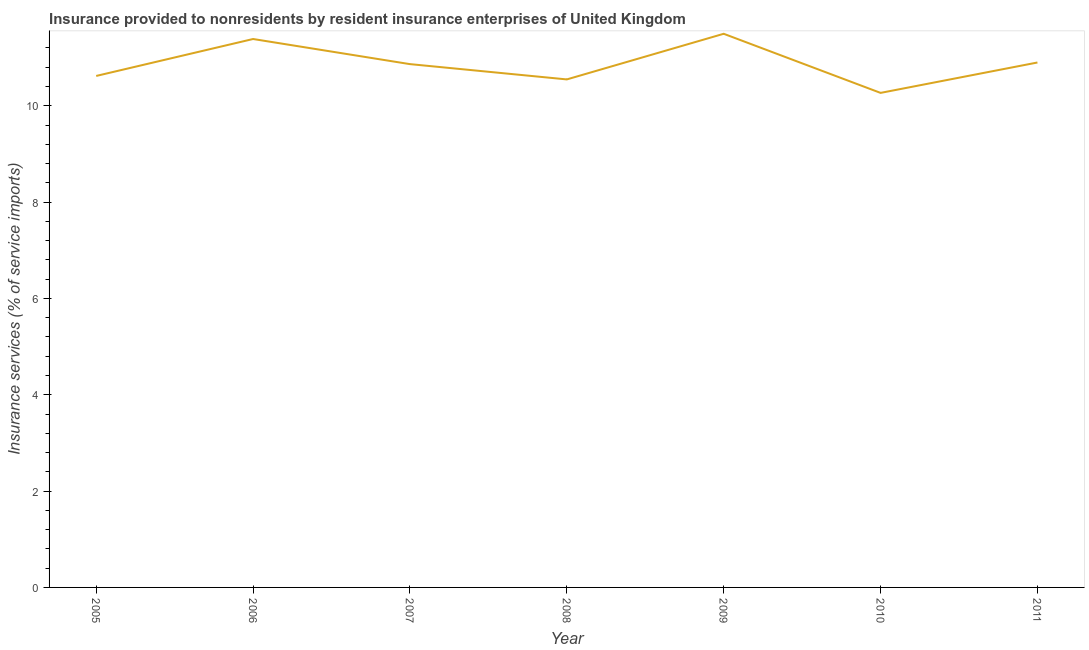What is the insurance and financial services in 2009?
Your answer should be very brief. 11.5. Across all years, what is the maximum insurance and financial services?
Offer a very short reply. 11.5. Across all years, what is the minimum insurance and financial services?
Give a very brief answer. 10.27. In which year was the insurance and financial services maximum?
Make the answer very short. 2009. In which year was the insurance and financial services minimum?
Your answer should be very brief. 2010. What is the sum of the insurance and financial services?
Your answer should be compact. 76.08. What is the difference between the insurance and financial services in 2009 and 2010?
Provide a succinct answer. 1.23. What is the average insurance and financial services per year?
Your response must be concise. 10.87. What is the median insurance and financial services?
Provide a succinct answer. 10.87. In how many years, is the insurance and financial services greater than 5.6 %?
Offer a very short reply. 7. What is the ratio of the insurance and financial services in 2005 to that in 2006?
Give a very brief answer. 0.93. What is the difference between the highest and the second highest insurance and financial services?
Your response must be concise. 0.11. What is the difference between the highest and the lowest insurance and financial services?
Provide a short and direct response. 1.23. In how many years, is the insurance and financial services greater than the average insurance and financial services taken over all years?
Provide a short and direct response. 3. How many years are there in the graph?
Provide a short and direct response. 7. Does the graph contain grids?
Your response must be concise. No. What is the title of the graph?
Your response must be concise. Insurance provided to nonresidents by resident insurance enterprises of United Kingdom. What is the label or title of the X-axis?
Provide a short and direct response. Year. What is the label or title of the Y-axis?
Provide a short and direct response. Insurance services (% of service imports). What is the Insurance services (% of service imports) in 2005?
Ensure brevity in your answer.  10.62. What is the Insurance services (% of service imports) of 2006?
Your response must be concise. 11.39. What is the Insurance services (% of service imports) of 2007?
Provide a succinct answer. 10.87. What is the Insurance services (% of service imports) in 2008?
Your answer should be very brief. 10.55. What is the Insurance services (% of service imports) of 2009?
Provide a succinct answer. 11.5. What is the Insurance services (% of service imports) of 2010?
Provide a short and direct response. 10.27. What is the Insurance services (% of service imports) of 2011?
Your response must be concise. 10.9. What is the difference between the Insurance services (% of service imports) in 2005 and 2006?
Make the answer very short. -0.77. What is the difference between the Insurance services (% of service imports) in 2005 and 2007?
Your answer should be very brief. -0.25. What is the difference between the Insurance services (% of service imports) in 2005 and 2008?
Provide a short and direct response. 0.07. What is the difference between the Insurance services (% of service imports) in 2005 and 2009?
Offer a terse response. -0.88. What is the difference between the Insurance services (% of service imports) in 2005 and 2010?
Make the answer very short. 0.35. What is the difference between the Insurance services (% of service imports) in 2005 and 2011?
Provide a succinct answer. -0.28. What is the difference between the Insurance services (% of service imports) in 2006 and 2007?
Offer a very short reply. 0.52. What is the difference between the Insurance services (% of service imports) in 2006 and 2008?
Give a very brief answer. 0.84. What is the difference between the Insurance services (% of service imports) in 2006 and 2009?
Give a very brief answer. -0.11. What is the difference between the Insurance services (% of service imports) in 2006 and 2010?
Provide a short and direct response. 1.12. What is the difference between the Insurance services (% of service imports) in 2006 and 2011?
Provide a succinct answer. 0.49. What is the difference between the Insurance services (% of service imports) in 2007 and 2008?
Make the answer very short. 0.32. What is the difference between the Insurance services (% of service imports) in 2007 and 2009?
Give a very brief answer. -0.63. What is the difference between the Insurance services (% of service imports) in 2007 and 2010?
Ensure brevity in your answer.  0.6. What is the difference between the Insurance services (% of service imports) in 2007 and 2011?
Give a very brief answer. -0.03. What is the difference between the Insurance services (% of service imports) in 2008 and 2009?
Ensure brevity in your answer.  -0.95. What is the difference between the Insurance services (% of service imports) in 2008 and 2010?
Your response must be concise. 0.28. What is the difference between the Insurance services (% of service imports) in 2008 and 2011?
Your answer should be very brief. -0.35. What is the difference between the Insurance services (% of service imports) in 2009 and 2010?
Make the answer very short. 1.23. What is the difference between the Insurance services (% of service imports) in 2009 and 2011?
Provide a succinct answer. 0.6. What is the difference between the Insurance services (% of service imports) in 2010 and 2011?
Make the answer very short. -0.63. What is the ratio of the Insurance services (% of service imports) in 2005 to that in 2006?
Your answer should be very brief. 0.93. What is the ratio of the Insurance services (% of service imports) in 2005 to that in 2007?
Keep it short and to the point. 0.98. What is the ratio of the Insurance services (% of service imports) in 2005 to that in 2009?
Offer a terse response. 0.92. What is the ratio of the Insurance services (% of service imports) in 2005 to that in 2010?
Make the answer very short. 1.03. What is the ratio of the Insurance services (% of service imports) in 2006 to that in 2007?
Offer a very short reply. 1.05. What is the ratio of the Insurance services (% of service imports) in 2006 to that in 2009?
Give a very brief answer. 0.99. What is the ratio of the Insurance services (% of service imports) in 2006 to that in 2010?
Your answer should be compact. 1.11. What is the ratio of the Insurance services (% of service imports) in 2006 to that in 2011?
Give a very brief answer. 1.04. What is the ratio of the Insurance services (% of service imports) in 2007 to that in 2008?
Keep it short and to the point. 1.03. What is the ratio of the Insurance services (% of service imports) in 2007 to that in 2009?
Keep it short and to the point. 0.94. What is the ratio of the Insurance services (% of service imports) in 2007 to that in 2010?
Provide a short and direct response. 1.06. What is the ratio of the Insurance services (% of service imports) in 2008 to that in 2009?
Provide a succinct answer. 0.92. What is the ratio of the Insurance services (% of service imports) in 2008 to that in 2011?
Offer a very short reply. 0.97. What is the ratio of the Insurance services (% of service imports) in 2009 to that in 2010?
Your response must be concise. 1.12. What is the ratio of the Insurance services (% of service imports) in 2009 to that in 2011?
Offer a terse response. 1.05. What is the ratio of the Insurance services (% of service imports) in 2010 to that in 2011?
Give a very brief answer. 0.94. 